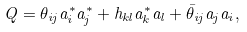Convert formula to latex. <formula><loc_0><loc_0><loc_500><loc_500>Q = \theta _ { i j } a _ { i } ^ { * } a _ { j } ^ { * } + h _ { k l } a _ { k } ^ { * } a _ { l } + \bar { \theta } _ { i j } a _ { j } a _ { i } ,</formula> 